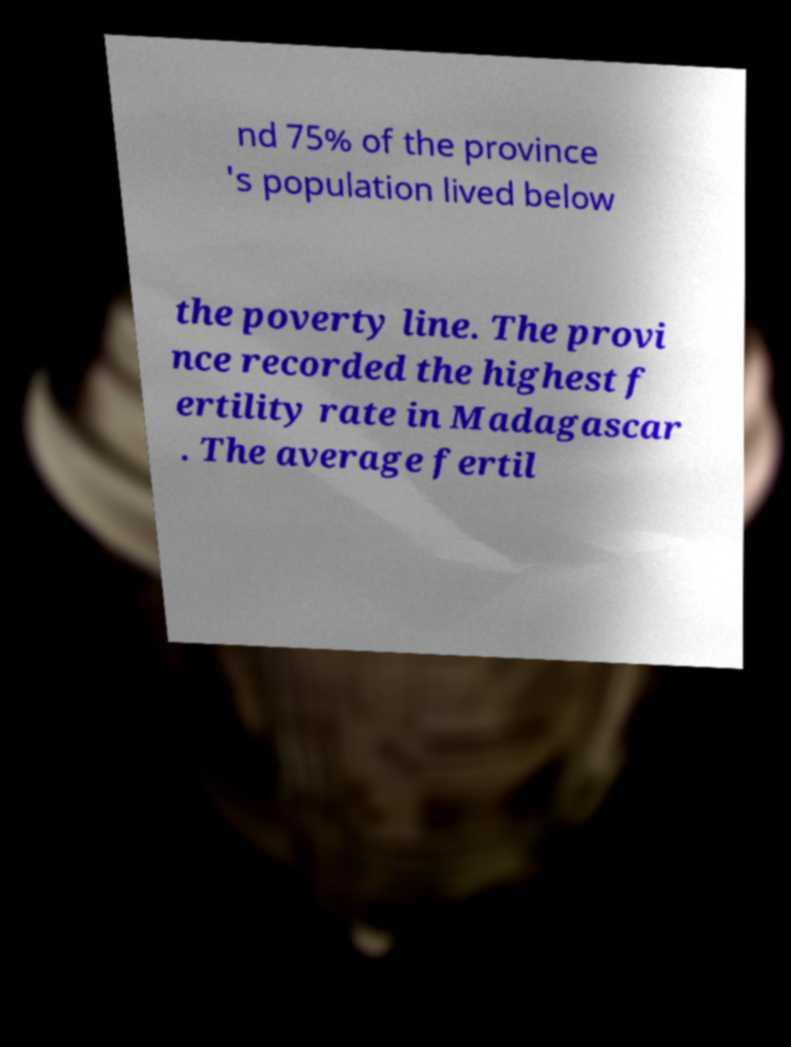There's text embedded in this image that I need extracted. Can you transcribe it verbatim? nd 75% of the province 's population lived below the poverty line. The provi nce recorded the highest f ertility rate in Madagascar . The average fertil 